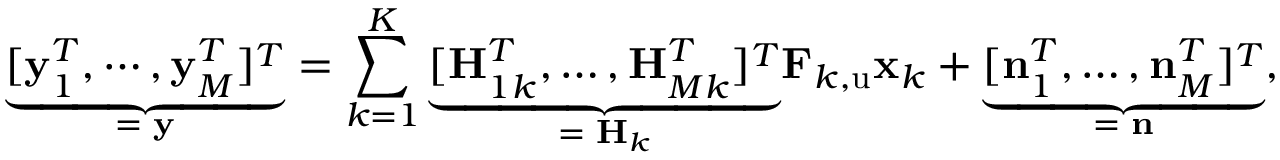Convert formula to latex. <formula><loc_0><loc_0><loc_500><loc_500>\underset { = \, y } { \underbrace { [ y _ { 1 } ^ { T } , \cdots , y _ { M } ^ { T } ] ^ { T } } } = \sum _ { k = 1 } ^ { K } { \underset { = \, H _ { k } } { \underbrace { [ H _ { 1 k } ^ { T } , \dots , H _ { M k } ^ { T } ] ^ { T } } } F _ { k , u } x _ { k } } + \underset { = \, n } { \underbrace { [ n _ { 1 } ^ { T } , \dots , n _ { M } ^ { T } ] ^ { T } } } ,</formula> 